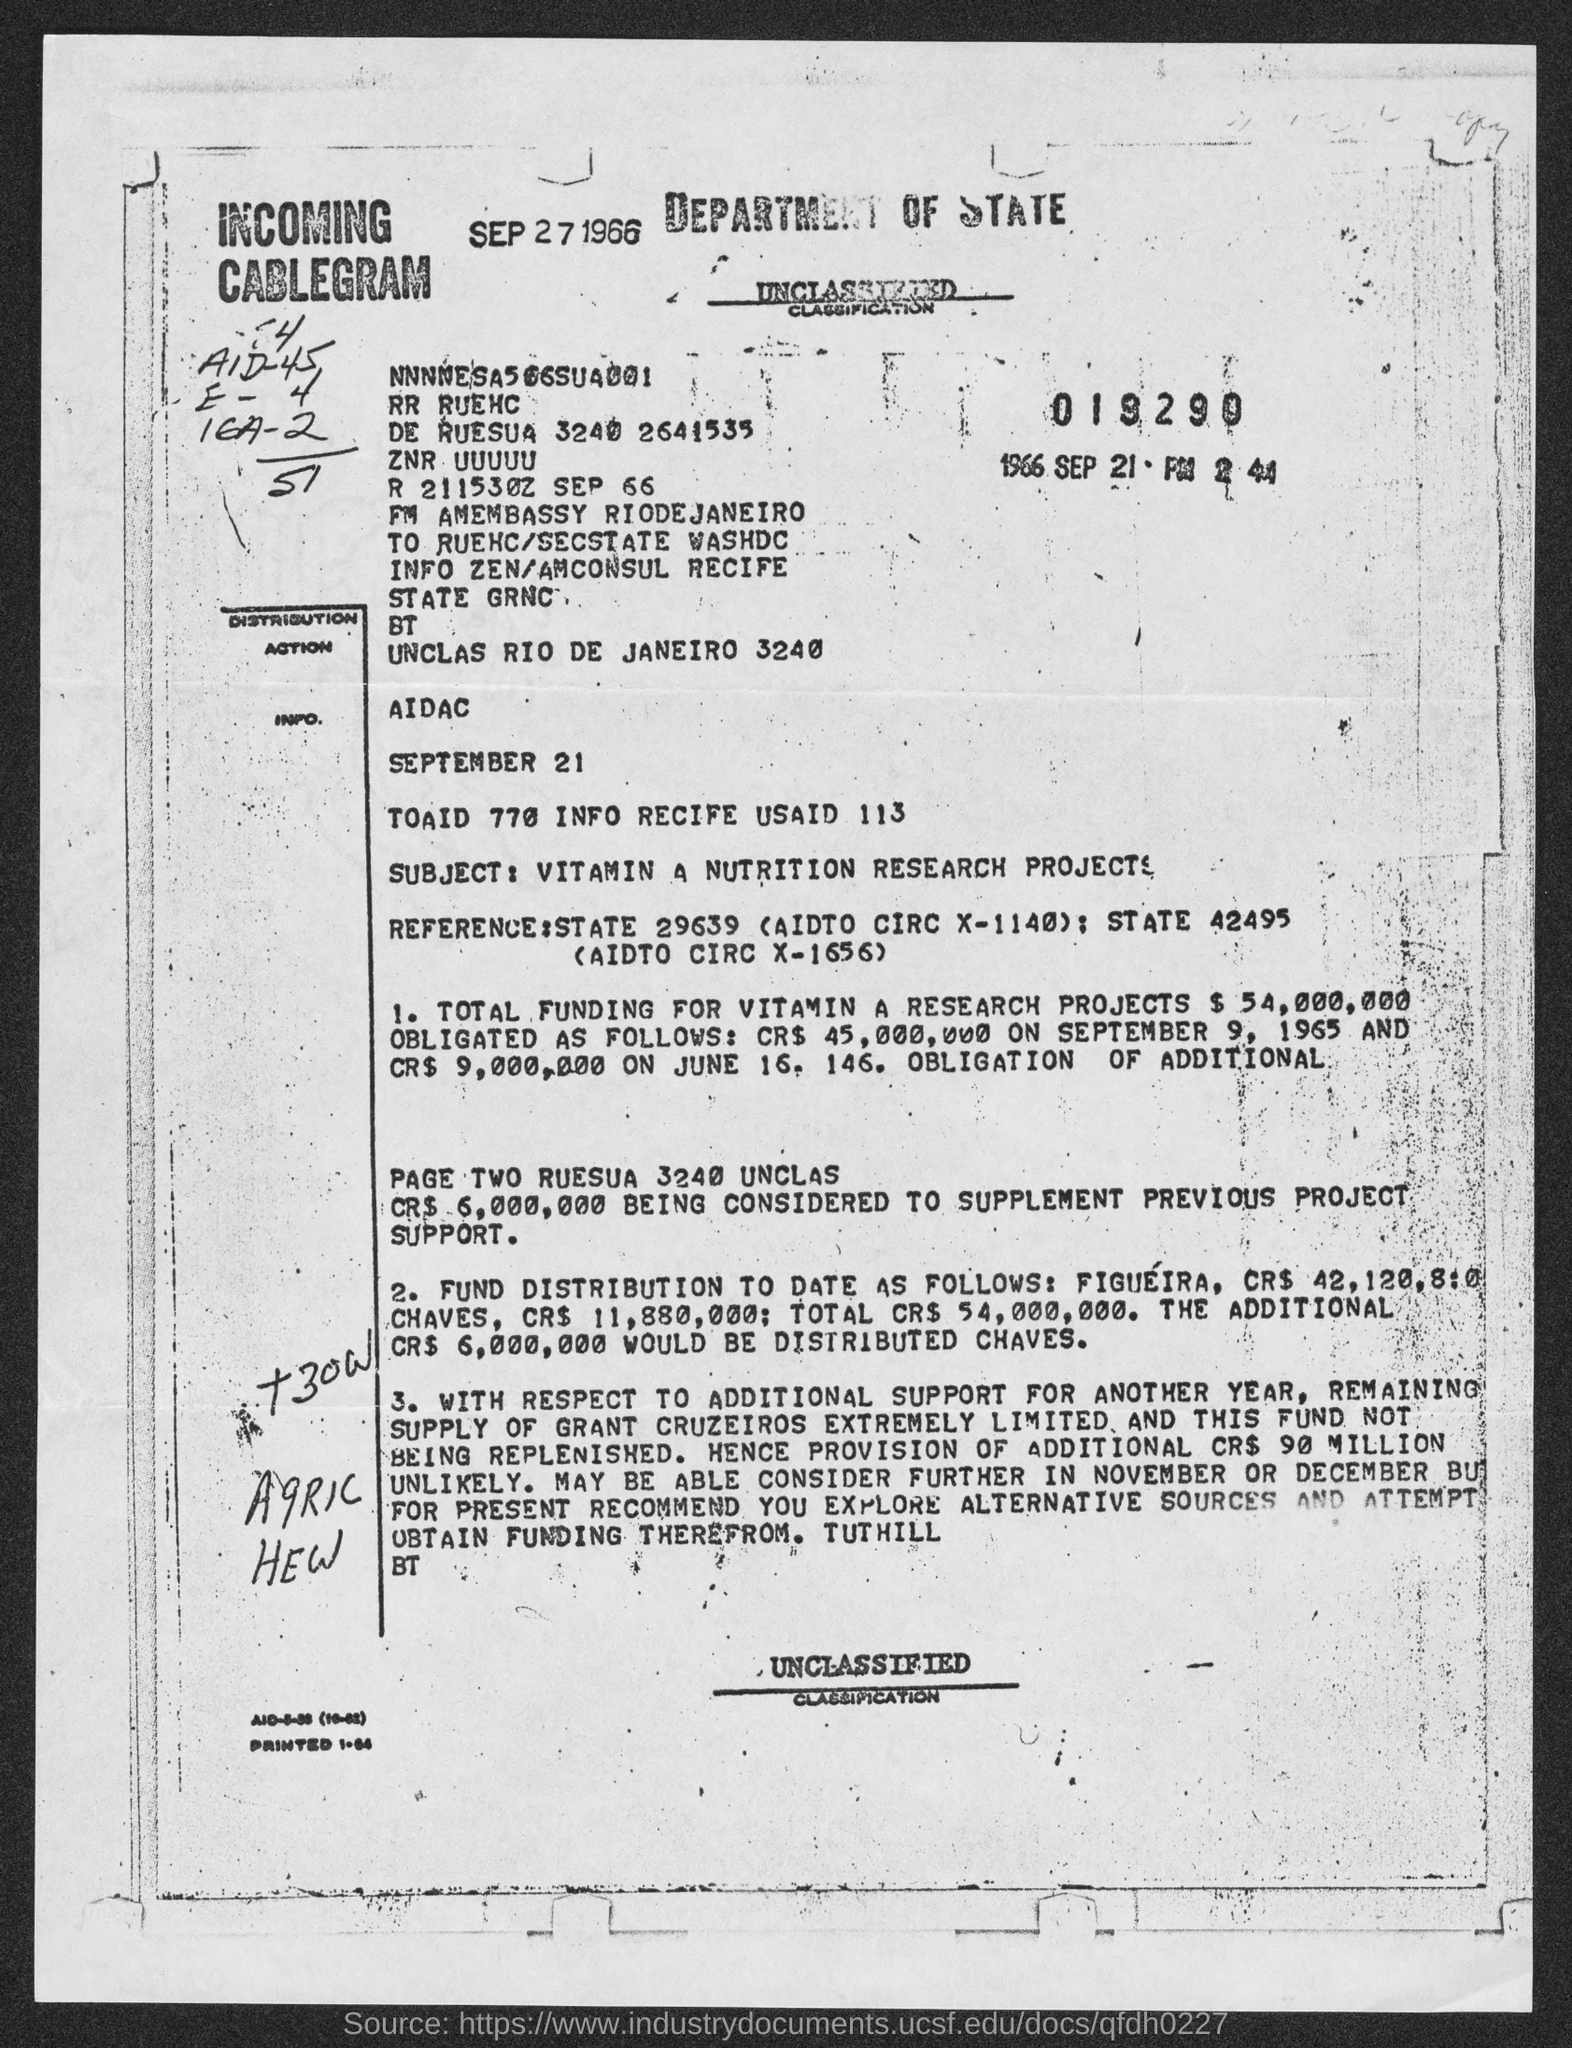Point out several critical features in this image. This document pertains to the subject of Vitamin A Nutrition research projects. 